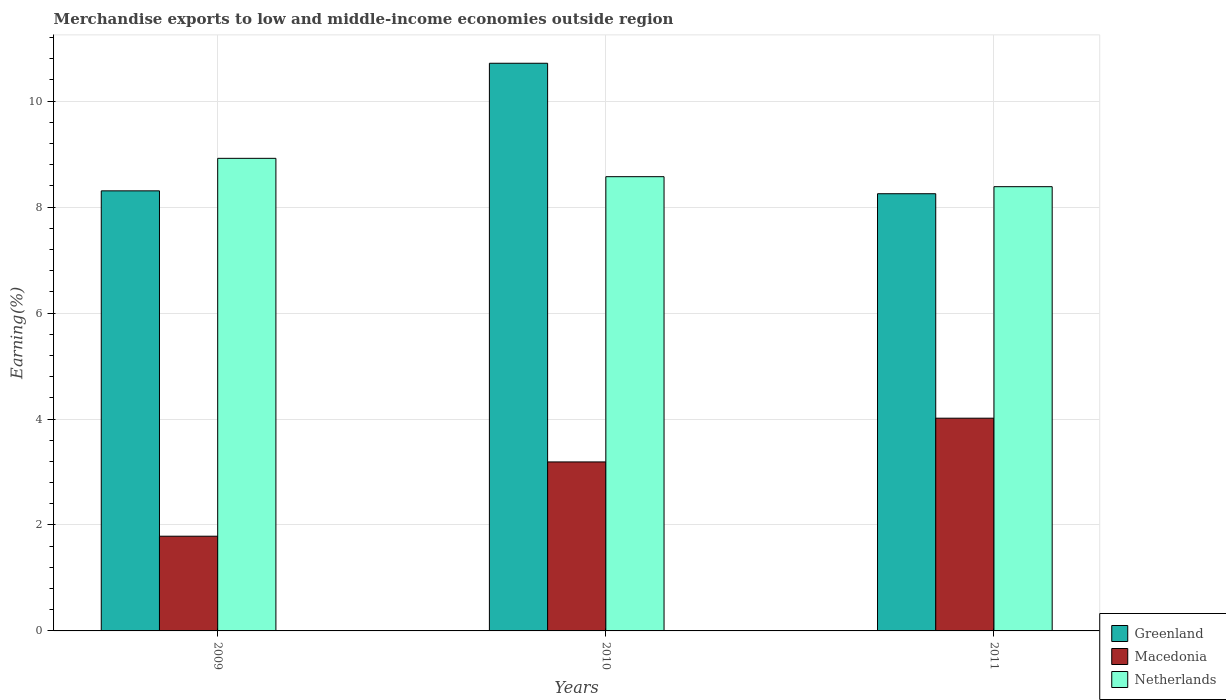How many different coloured bars are there?
Make the answer very short. 3. How many groups of bars are there?
Give a very brief answer. 3. Are the number of bars per tick equal to the number of legend labels?
Give a very brief answer. Yes. What is the percentage of amount earned from merchandise exports in Greenland in 2009?
Your response must be concise. 8.31. Across all years, what is the maximum percentage of amount earned from merchandise exports in Greenland?
Make the answer very short. 10.72. Across all years, what is the minimum percentage of amount earned from merchandise exports in Netherlands?
Provide a succinct answer. 8.39. What is the total percentage of amount earned from merchandise exports in Macedonia in the graph?
Give a very brief answer. 8.99. What is the difference between the percentage of amount earned from merchandise exports in Greenland in 2009 and that in 2010?
Offer a very short reply. -2.41. What is the difference between the percentage of amount earned from merchandise exports in Netherlands in 2011 and the percentage of amount earned from merchandise exports in Greenland in 2009?
Your response must be concise. 0.08. What is the average percentage of amount earned from merchandise exports in Macedonia per year?
Your answer should be very brief. 3. In the year 2011, what is the difference between the percentage of amount earned from merchandise exports in Greenland and percentage of amount earned from merchandise exports in Netherlands?
Ensure brevity in your answer.  -0.13. What is the ratio of the percentage of amount earned from merchandise exports in Greenland in 2009 to that in 2011?
Offer a terse response. 1.01. Is the percentage of amount earned from merchandise exports in Macedonia in 2009 less than that in 2010?
Give a very brief answer. Yes. What is the difference between the highest and the second highest percentage of amount earned from merchandise exports in Greenland?
Offer a very short reply. 2.41. What is the difference between the highest and the lowest percentage of amount earned from merchandise exports in Greenland?
Ensure brevity in your answer.  2.46. What does the 2nd bar from the left in 2009 represents?
Keep it short and to the point. Macedonia. What does the 2nd bar from the right in 2011 represents?
Keep it short and to the point. Macedonia. Is it the case that in every year, the sum of the percentage of amount earned from merchandise exports in Netherlands and percentage of amount earned from merchandise exports in Greenland is greater than the percentage of amount earned from merchandise exports in Macedonia?
Your answer should be compact. Yes. How many bars are there?
Give a very brief answer. 9. Are all the bars in the graph horizontal?
Make the answer very short. No. Are the values on the major ticks of Y-axis written in scientific E-notation?
Your answer should be compact. No. How are the legend labels stacked?
Offer a very short reply. Vertical. What is the title of the graph?
Your answer should be very brief. Merchandise exports to low and middle-income economies outside region. What is the label or title of the Y-axis?
Your response must be concise. Earning(%). What is the Earning(%) in Greenland in 2009?
Offer a very short reply. 8.31. What is the Earning(%) of Macedonia in 2009?
Ensure brevity in your answer.  1.79. What is the Earning(%) of Netherlands in 2009?
Offer a terse response. 8.92. What is the Earning(%) of Greenland in 2010?
Your answer should be very brief. 10.72. What is the Earning(%) of Macedonia in 2010?
Offer a terse response. 3.19. What is the Earning(%) in Netherlands in 2010?
Your response must be concise. 8.58. What is the Earning(%) of Greenland in 2011?
Keep it short and to the point. 8.25. What is the Earning(%) in Macedonia in 2011?
Your response must be concise. 4.02. What is the Earning(%) in Netherlands in 2011?
Make the answer very short. 8.39. Across all years, what is the maximum Earning(%) of Greenland?
Your response must be concise. 10.72. Across all years, what is the maximum Earning(%) of Macedonia?
Offer a very short reply. 4.02. Across all years, what is the maximum Earning(%) in Netherlands?
Your answer should be compact. 8.92. Across all years, what is the minimum Earning(%) of Greenland?
Keep it short and to the point. 8.25. Across all years, what is the minimum Earning(%) of Macedonia?
Make the answer very short. 1.79. Across all years, what is the minimum Earning(%) of Netherlands?
Offer a very short reply. 8.39. What is the total Earning(%) of Greenland in the graph?
Offer a very short reply. 27.28. What is the total Earning(%) of Macedonia in the graph?
Your answer should be very brief. 8.99. What is the total Earning(%) in Netherlands in the graph?
Your answer should be very brief. 25.88. What is the difference between the Earning(%) in Greenland in 2009 and that in 2010?
Provide a succinct answer. -2.41. What is the difference between the Earning(%) in Macedonia in 2009 and that in 2010?
Make the answer very short. -1.4. What is the difference between the Earning(%) of Netherlands in 2009 and that in 2010?
Your response must be concise. 0.35. What is the difference between the Earning(%) of Greenland in 2009 and that in 2011?
Provide a succinct answer. 0.05. What is the difference between the Earning(%) of Macedonia in 2009 and that in 2011?
Offer a very short reply. -2.23. What is the difference between the Earning(%) in Netherlands in 2009 and that in 2011?
Your answer should be very brief. 0.54. What is the difference between the Earning(%) of Greenland in 2010 and that in 2011?
Ensure brevity in your answer.  2.46. What is the difference between the Earning(%) in Macedonia in 2010 and that in 2011?
Provide a succinct answer. -0.83. What is the difference between the Earning(%) of Netherlands in 2010 and that in 2011?
Your answer should be very brief. 0.19. What is the difference between the Earning(%) of Greenland in 2009 and the Earning(%) of Macedonia in 2010?
Your response must be concise. 5.12. What is the difference between the Earning(%) in Greenland in 2009 and the Earning(%) in Netherlands in 2010?
Provide a succinct answer. -0.27. What is the difference between the Earning(%) in Macedonia in 2009 and the Earning(%) in Netherlands in 2010?
Offer a terse response. -6.79. What is the difference between the Earning(%) in Greenland in 2009 and the Earning(%) in Macedonia in 2011?
Offer a very short reply. 4.29. What is the difference between the Earning(%) of Greenland in 2009 and the Earning(%) of Netherlands in 2011?
Provide a short and direct response. -0.08. What is the difference between the Earning(%) in Macedonia in 2009 and the Earning(%) in Netherlands in 2011?
Ensure brevity in your answer.  -6.6. What is the difference between the Earning(%) in Greenland in 2010 and the Earning(%) in Macedonia in 2011?
Your answer should be compact. 6.7. What is the difference between the Earning(%) of Greenland in 2010 and the Earning(%) of Netherlands in 2011?
Offer a very short reply. 2.33. What is the difference between the Earning(%) in Macedonia in 2010 and the Earning(%) in Netherlands in 2011?
Keep it short and to the point. -5.2. What is the average Earning(%) in Greenland per year?
Provide a short and direct response. 9.09. What is the average Earning(%) in Macedonia per year?
Your response must be concise. 3. What is the average Earning(%) in Netherlands per year?
Provide a short and direct response. 8.63. In the year 2009, what is the difference between the Earning(%) of Greenland and Earning(%) of Macedonia?
Give a very brief answer. 6.52. In the year 2009, what is the difference between the Earning(%) in Greenland and Earning(%) in Netherlands?
Your answer should be very brief. -0.61. In the year 2009, what is the difference between the Earning(%) in Macedonia and Earning(%) in Netherlands?
Your answer should be very brief. -7.13. In the year 2010, what is the difference between the Earning(%) of Greenland and Earning(%) of Macedonia?
Your response must be concise. 7.53. In the year 2010, what is the difference between the Earning(%) in Greenland and Earning(%) in Netherlands?
Your answer should be compact. 2.14. In the year 2010, what is the difference between the Earning(%) of Macedonia and Earning(%) of Netherlands?
Ensure brevity in your answer.  -5.38. In the year 2011, what is the difference between the Earning(%) of Greenland and Earning(%) of Macedonia?
Offer a very short reply. 4.24. In the year 2011, what is the difference between the Earning(%) in Greenland and Earning(%) in Netherlands?
Provide a succinct answer. -0.13. In the year 2011, what is the difference between the Earning(%) of Macedonia and Earning(%) of Netherlands?
Your answer should be very brief. -4.37. What is the ratio of the Earning(%) in Greenland in 2009 to that in 2010?
Your answer should be very brief. 0.78. What is the ratio of the Earning(%) of Macedonia in 2009 to that in 2010?
Make the answer very short. 0.56. What is the ratio of the Earning(%) in Netherlands in 2009 to that in 2010?
Your response must be concise. 1.04. What is the ratio of the Earning(%) of Greenland in 2009 to that in 2011?
Offer a terse response. 1.01. What is the ratio of the Earning(%) in Macedonia in 2009 to that in 2011?
Your response must be concise. 0.45. What is the ratio of the Earning(%) of Netherlands in 2009 to that in 2011?
Offer a terse response. 1.06. What is the ratio of the Earning(%) in Greenland in 2010 to that in 2011?
Provide a short and direct response. 1.3. What is the ratio of the Earning(%) in Macedonia in 2010 to that in 2011?
Offer a terse response. 0.79. What is the ratio of the Earning(%) in Netherlands in 2010 to that in 2011?
Offer a very short reply. 1.02. What is the difference between the highest and the second highest Earning(%) in Greenland?
Offer a very short reply. 2.41. What is the difference between the highest and the second highest Earning(%) of Macedonia?
Your answer should be compact. 0.83. What is the difference between the highest and the second highest Earning(%) of Netherlands?
Ensure brevity in your answer.  0.35. What is the difference between the highest and the lowest Earning(%) in Greenland?
Your answer should be very brief. 2.46. What is the difference between the highest and the lowest Earning(%) in Macedonia?
Ensure brevity in your answer.  2.23. What is the difference between the highest and the lowest Earning(%) in Netherlands?
Offer a terse response. 0.54. 